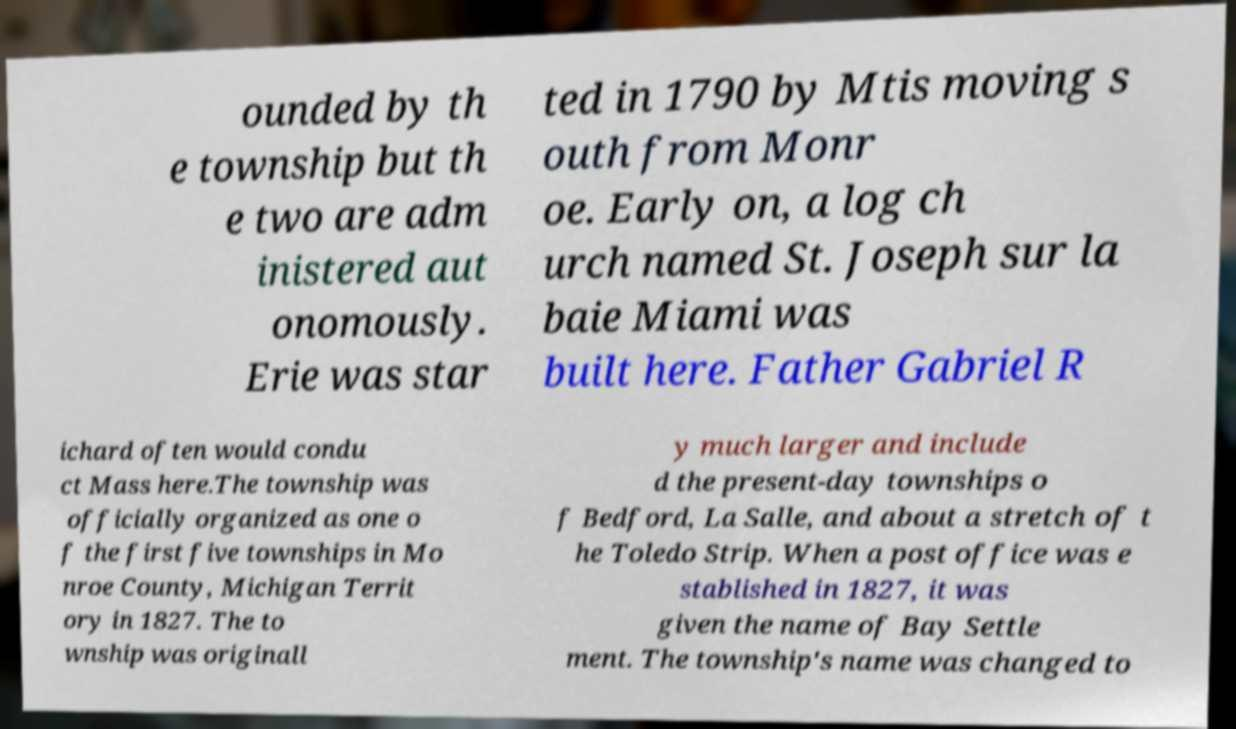Could you assist in decoding the text presented in this image and type it out clearly? ounded by th e township but th e two are adm inistered aut onomously. Erie was star ted in 1790 by Mtis moving s outh from Monr oe. Early on, a log ch urch named St. Joseph sur la baie Miami was built here. Father Gabriel R ichard often would condu ct Mass here.The township was officially organized as one o f the first five townships in Mo nroe County, Michigan Territ ory in 1827. The to wnship was originall y much larger and include d the present-day townships o f Bedford, La Salle, and about a stretch of t he Toledo Strip. When a post office was e stablished in 1827, it was given the name of Bay Settle ment. The township's name was changed to 